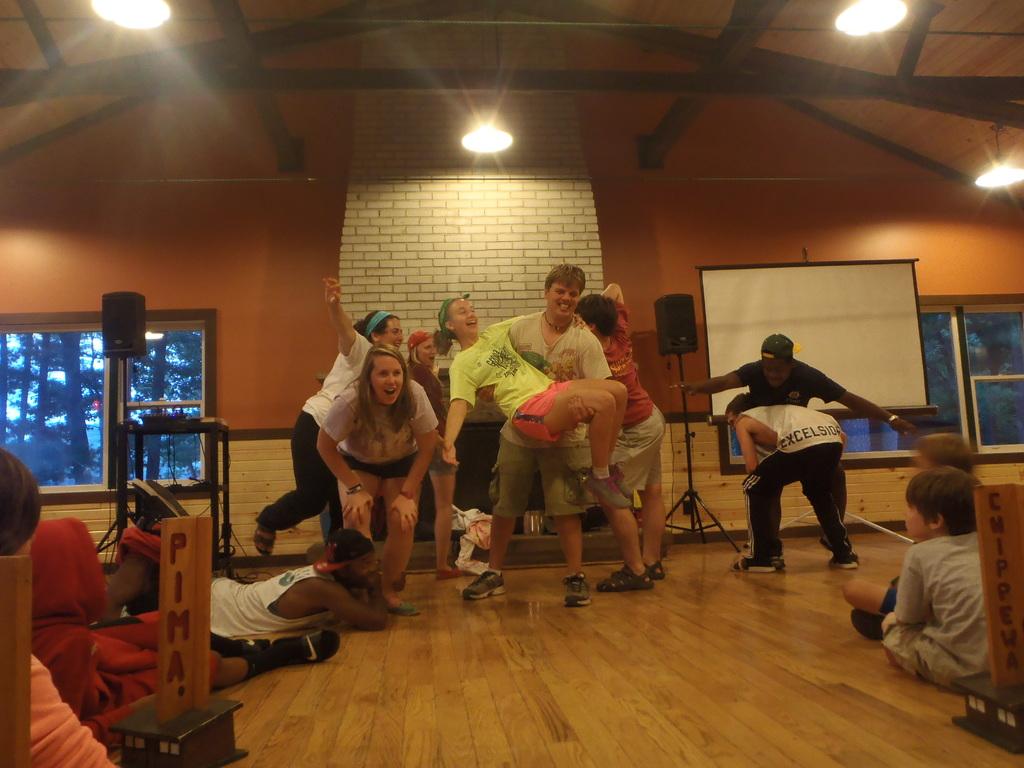What is written on the wooden sign on the right?
Provide a succinct answer. Chippewa. What is written on the sign on the left?
Keep it short and to the point. Pima. 